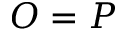Convert formula to latex. <formula><loc_0><loc_0><loc_500><loc_500>O = P</formula> 